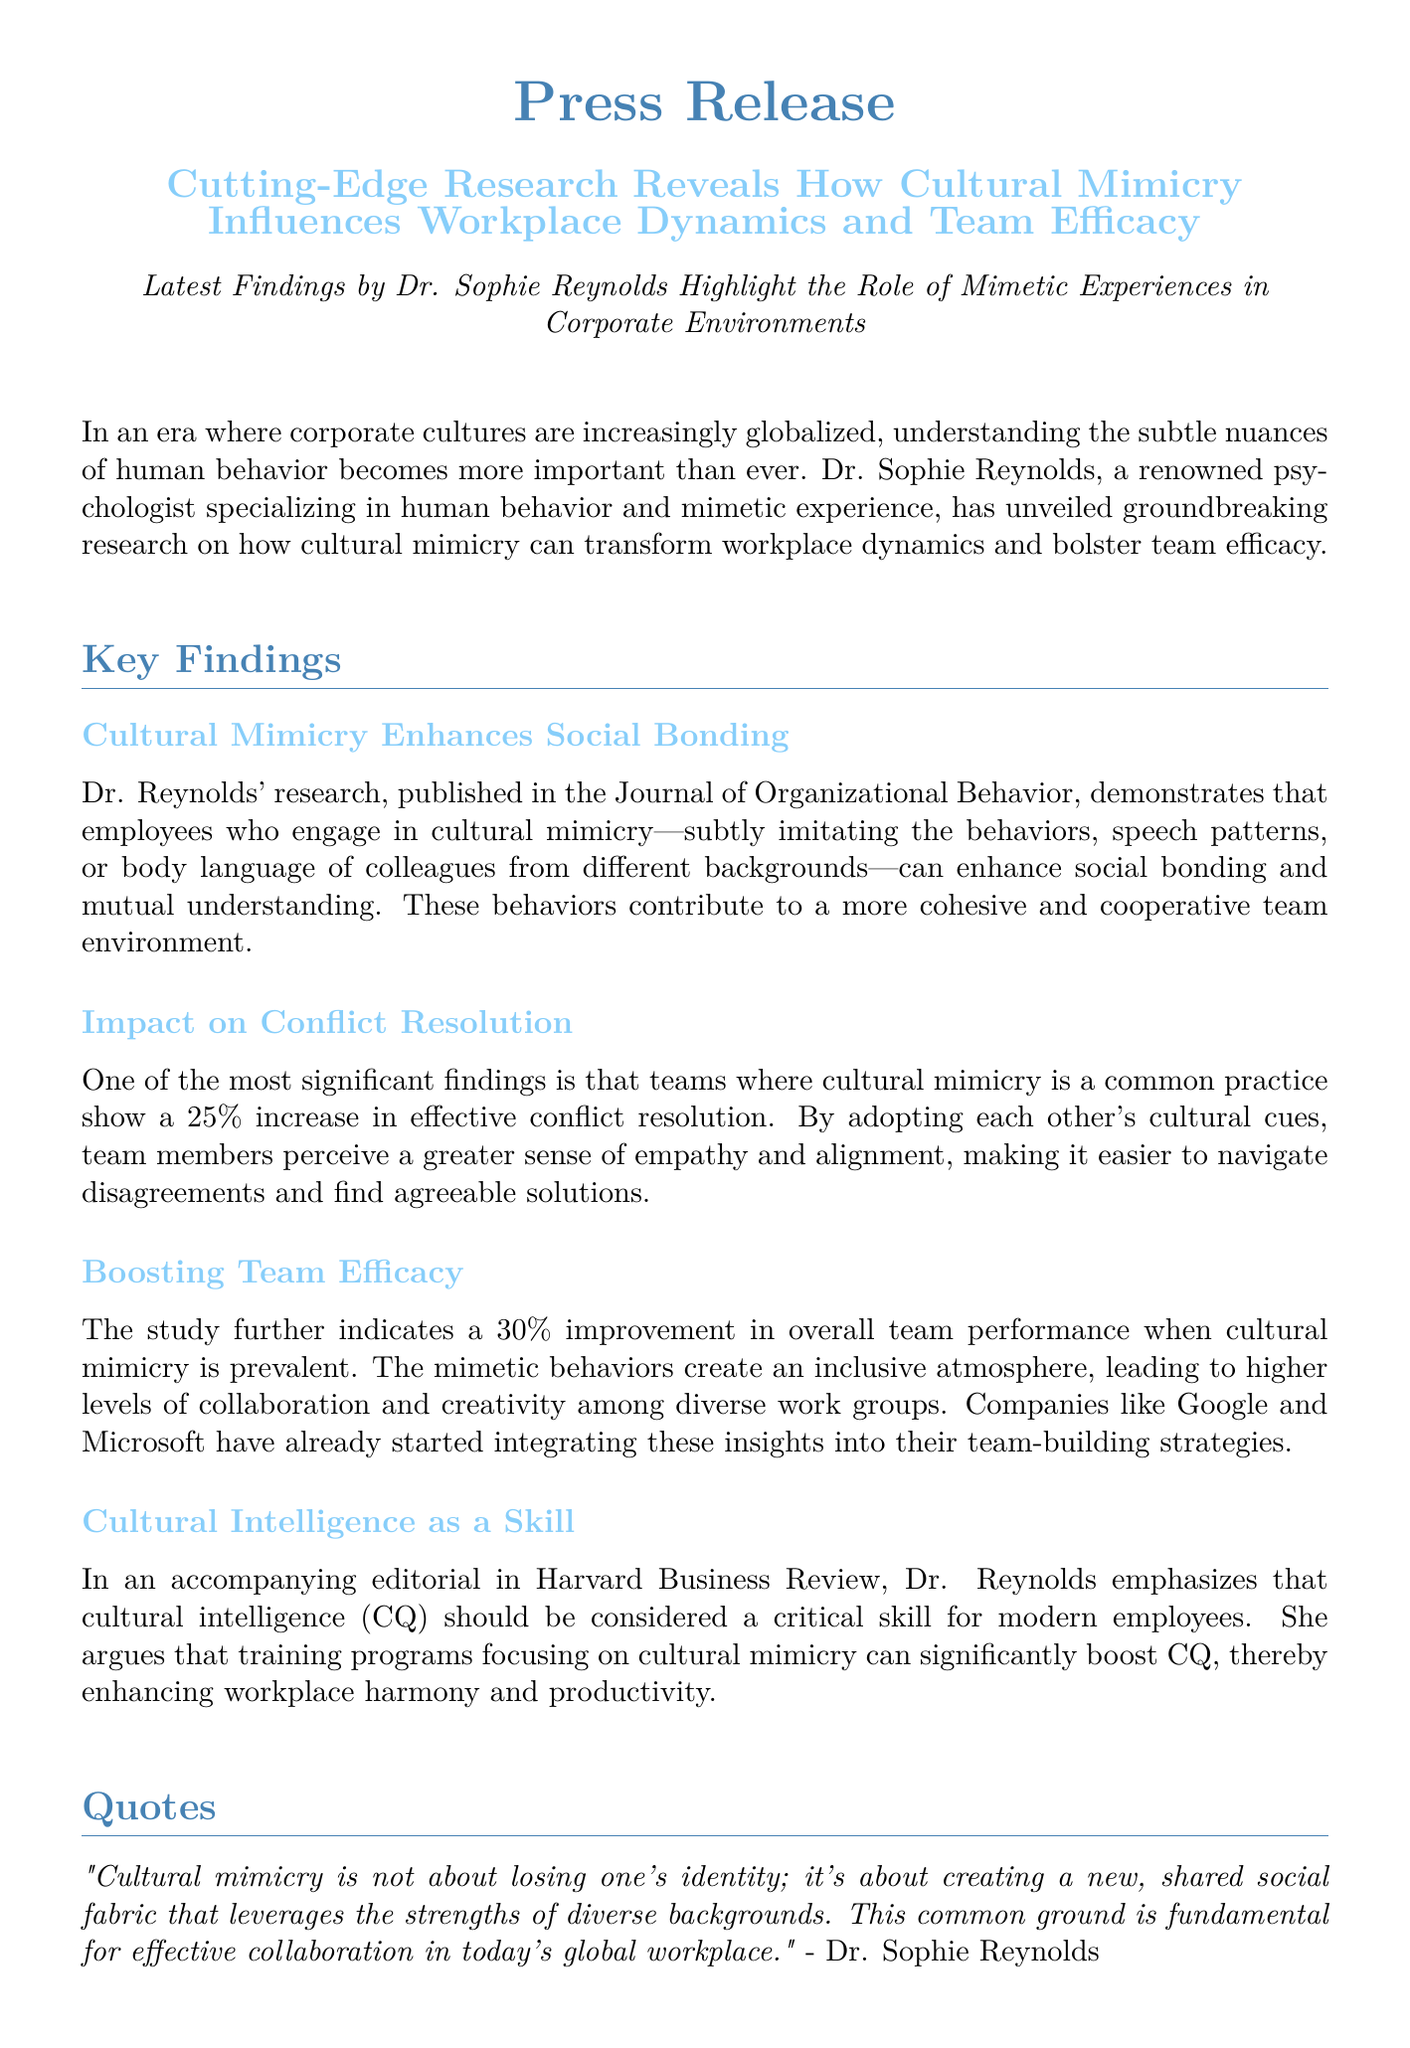What is the title of the research? The title of the research is highlighted in the document, focusing on cultural mimicry's influence in workplace dynamics and team efficacy.
Answer: Cutting-Edge Research Reveals How Cultural Mimicry Influences Workplace Dynamics and Team Efficacy Who conducted the research? The document states the research was conducted by Dr. Sophie Reynolds, a renowned psychologist.
Answer: Dr. Sophie Reynolds What is the percentage increase in effective conflict resolution due to cultural mimicry? The document specifies a significant finding indicating a 25% increase in effective conflict resolution in teams practicing cultural mimicry.
Answer: 25% Which companies are mentioned to be integrating these insights? The document mentions that certain companies have started integrating the research insights into their practices.
Answer: Google and Microsoft What does Dr. Reynolds suggest should be considered a critical skill for modern employees? The document cites Dr. Reynolds' emphasis on the importance of a particular skill for modern employees related to cultural interactions.
Answer: Cultural intelligence (CQ) How much improvement in overall team performance is indicated in the study? The document quantifies the improvement in overall team performance associated with cultural mimicry as mentioned in the study.
Answer: 30% What overarching theme does Dr. Reynolds emphasize regarding cultural mimicry? The document includes a quote from Dr. Reynolds highlighting a key theme regarding cultural mimicry's impact on identity and collaboration.
Answer: Creating a new, shared social fabric What type of publication featured Dr. Reynolds' research? The document mentions the journal where Dr. Reynolds' research was published, indicating its academic context.
Answer: Journal of Organizational Behavior 